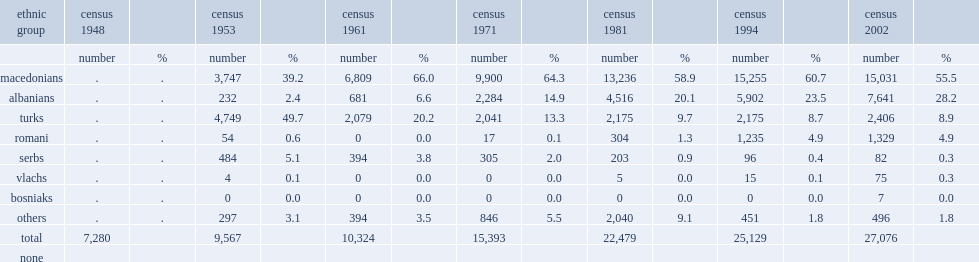Would you be able to parse every entry in this table? {'header': ['ethnic group', 'census 1948', '', 'census 1953', '', 'census 1961', '', 'census 1971', '', 'census 1981', '', 'census 1994', '', 'census 2002', ''], 'rows': [['', 'number', '%', 'number', '%', 'number', '%', 'number', '%', 'number', '%', 'number', '%', 'number', '%'], ['macedonians', '.', '.', '3,747', '39.2', '6,809', '66.0', '9,900', '64.3', '13,236', '58.9', '15,255', '60.7', '15,031', '55.5'], ['albanians', '.', '.', '232', '2.4', '681', '6.6', '2,284', '14.9', '4,516', '20.1', '5,902', '23.5', '7,641', '28.2'], ['turks', '.', '.', '4,749', '49.7', '2,079', '20.2', '2,041', '13.3', '2,175', '9.7', '2,175', '8.7', '2,406', '8.9'], ['romani', '.', '.', '54', '0.6', '0', '0.0', '17', '0.1', '304', '1.3', '1,235', '4.9', '1,329', '4.9'], ['serbs', '.', '.', '484', '5.1', '394', '3.8', '305', '2.0', '203', '0.9', '96', '0.4', '82', '0.3'], ['vlachs', '.', '.', '4', '0.1', '0', '0.0', '0', '0.0', '5', '0.0', '15', '0.1', '75', '0.3'], ['bosniaks', '.', '.', '0', '0.0', '0', '0.0', '0', '0.0', '0', '0.0', '0', '0.0', '7', '0.0'], ['others', '.', '.', '297', '3.1', '394', '3.5', '846', '5.5', '2,040', '9.1', '451', '1.8', '496', '1.8'], ['total', '7,280', '', '9,567', '', '10,324', '', '15,393', '', '22,479', '', '25,129', '', '27,076', ''], ['none', '', '', '', '', '', '', '', '', '', '', '', '', '', '']]} How many inhabitants did kicevo have in census 2002? 27076.0. 